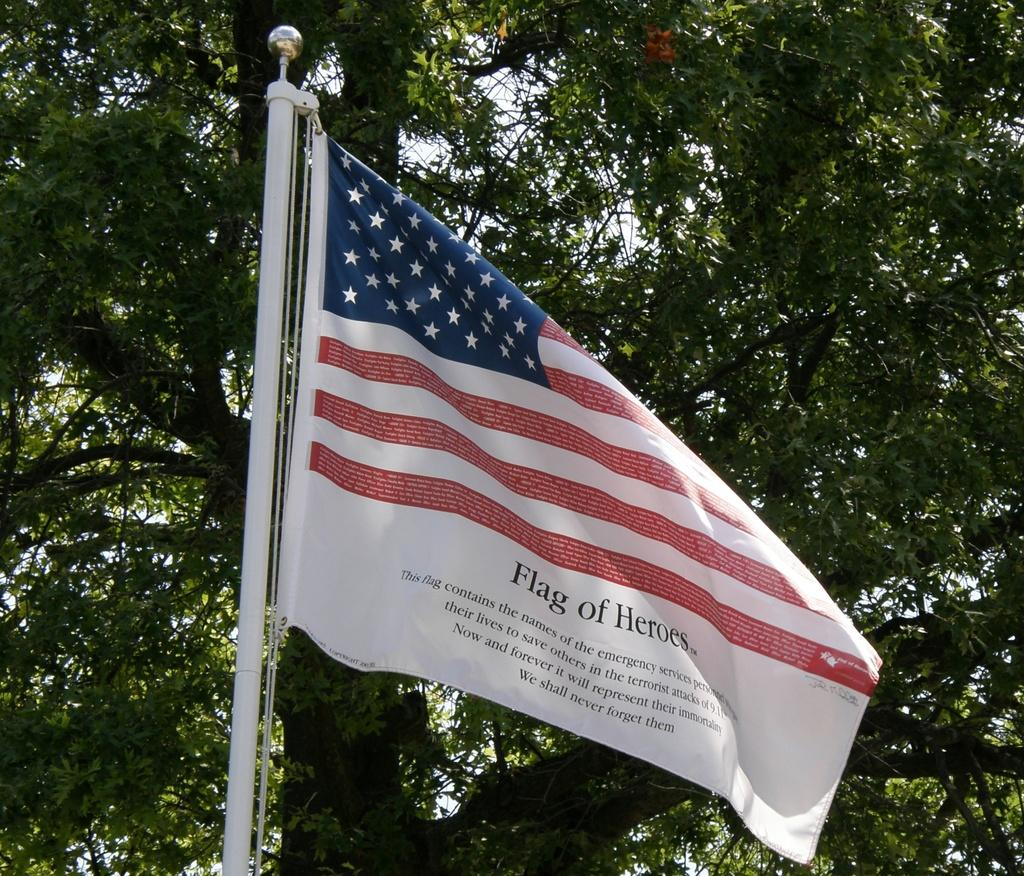What is the main object in the foreground of the image? There is a flag in the image. What can be seen in the background of the image? There is a tree in the background of the image. What is visible behind the tree in the background? The sky is visible behind the tree in the background. How does the zebra show respect to the flag in the image? There is no zebra present in the image, so it cannot show respect to the flag. 